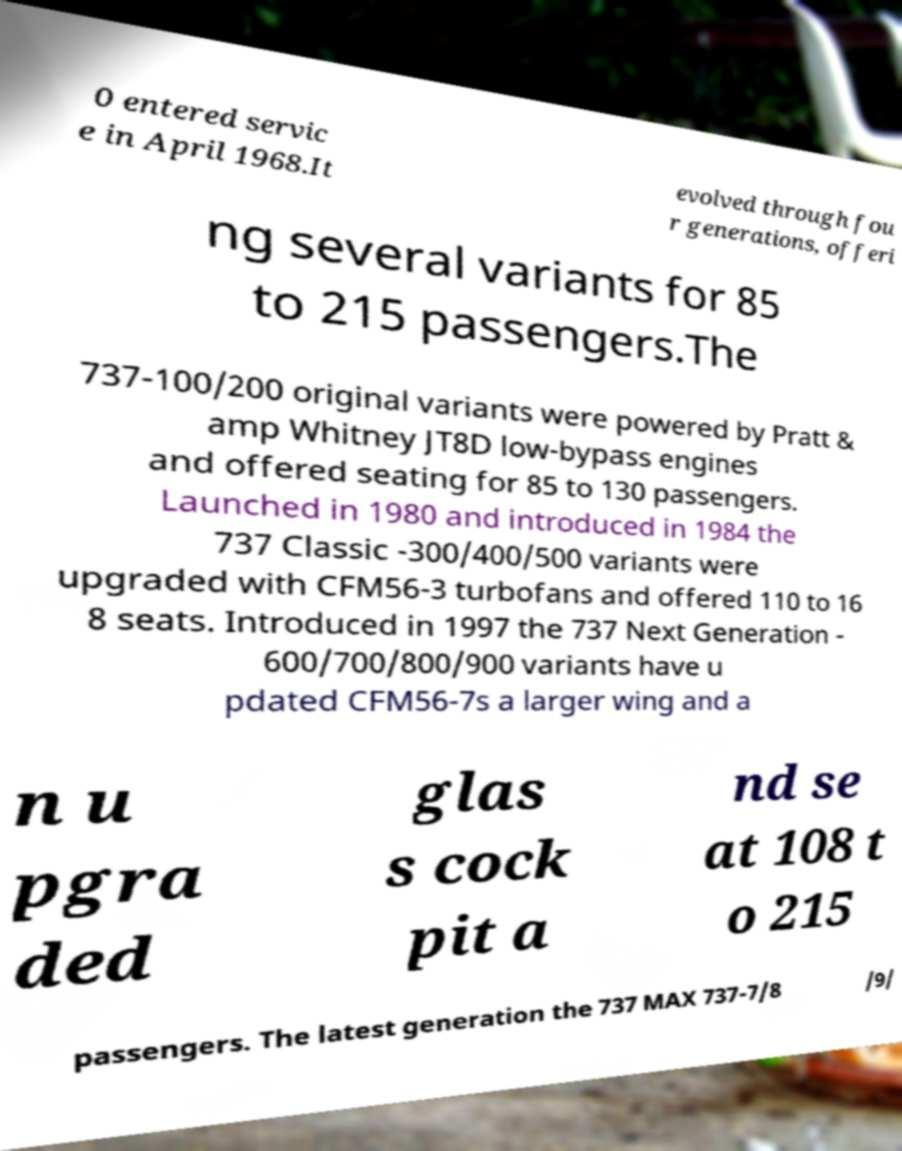Could you extract and type out the text from this image? 0 entered servic e in April 1968.It evolved through fou r generations, offeri ng several variants for 85 to 215 passengers.The 737-100/200 original variants were powered by Pratt & amp Whitney JT8D low-bypass engines and offered seating for 85 to 130 passengers. Launched in 1980 and introduced in 1984 the 737 Classic -300/400/500 variants were upgraded with CFM56-3 turbofans and offered 110 to 16 8 seats. Introduced in 1997 the 737 Next Generation - 600/700/800/900 variants have u pdated CFM56-7s a larger wing and a n u pgra ded glas s cock pit a nd se at 108 t o 215 passengers. The latest generation the 737 MAX 737-7/8 /9/ 